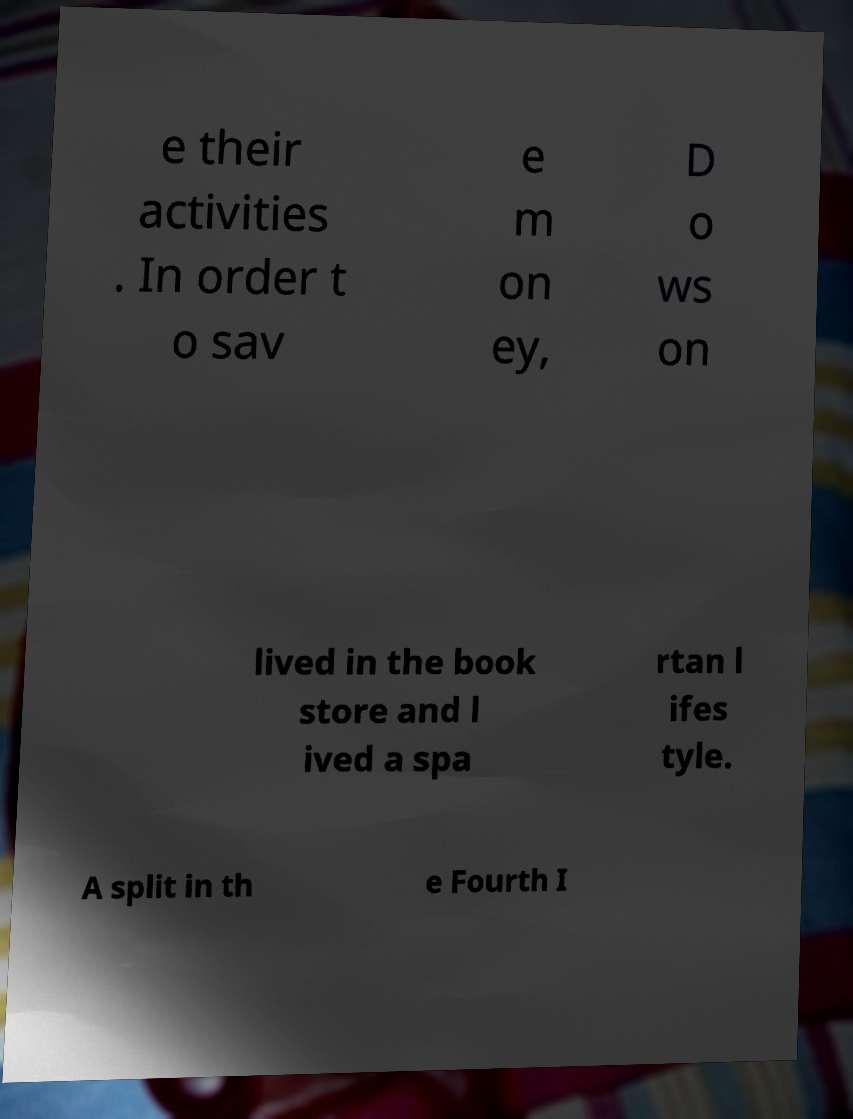There's text embedded in this image that I need extracted. Can you transcribe it verbatim? e their activities . In order t o sav e m on ey, D o ws on lived in the book store and l ived a spa rtan l ifes tyle. A split in th e Fourth I 